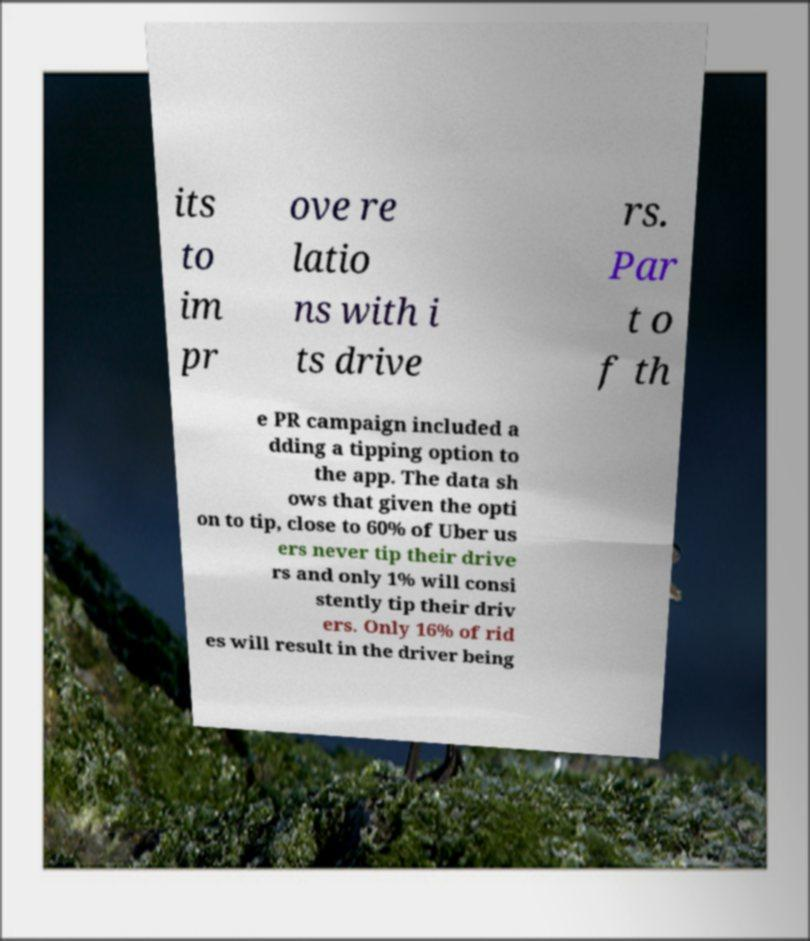Can you accurately transcribe the text from the provided image for me? its to im pr ove re latio ns with i ts drive rs. Par t o f th e PR campaign included a dding a tipping option to the app. The data sh ows that given the opti on to tip, close to 60% of Uber us ers never tip their drive rs and only 1% will consi stently tip their driv ers. Only 16% of rid es will result in the driver being 